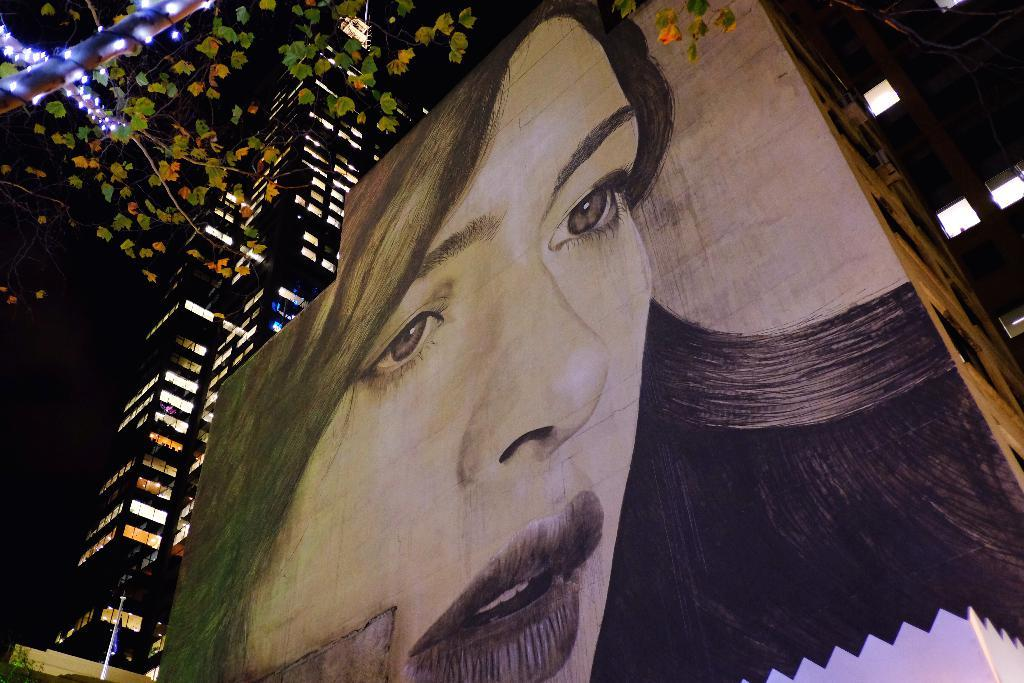What is depicted on the building in the image? There is a painting of a woman on a building in the image. Are there any other buildings visible in the image? Yes, there is another building beside the one with the painting. What can be seen in the left top corner of the image? There is a tree decorated with lights in the left top corner of the image. What impulse does the judge have when looking at the yak in the image? There is no judge or yak present in the image, so it is not possible to answer that question. 